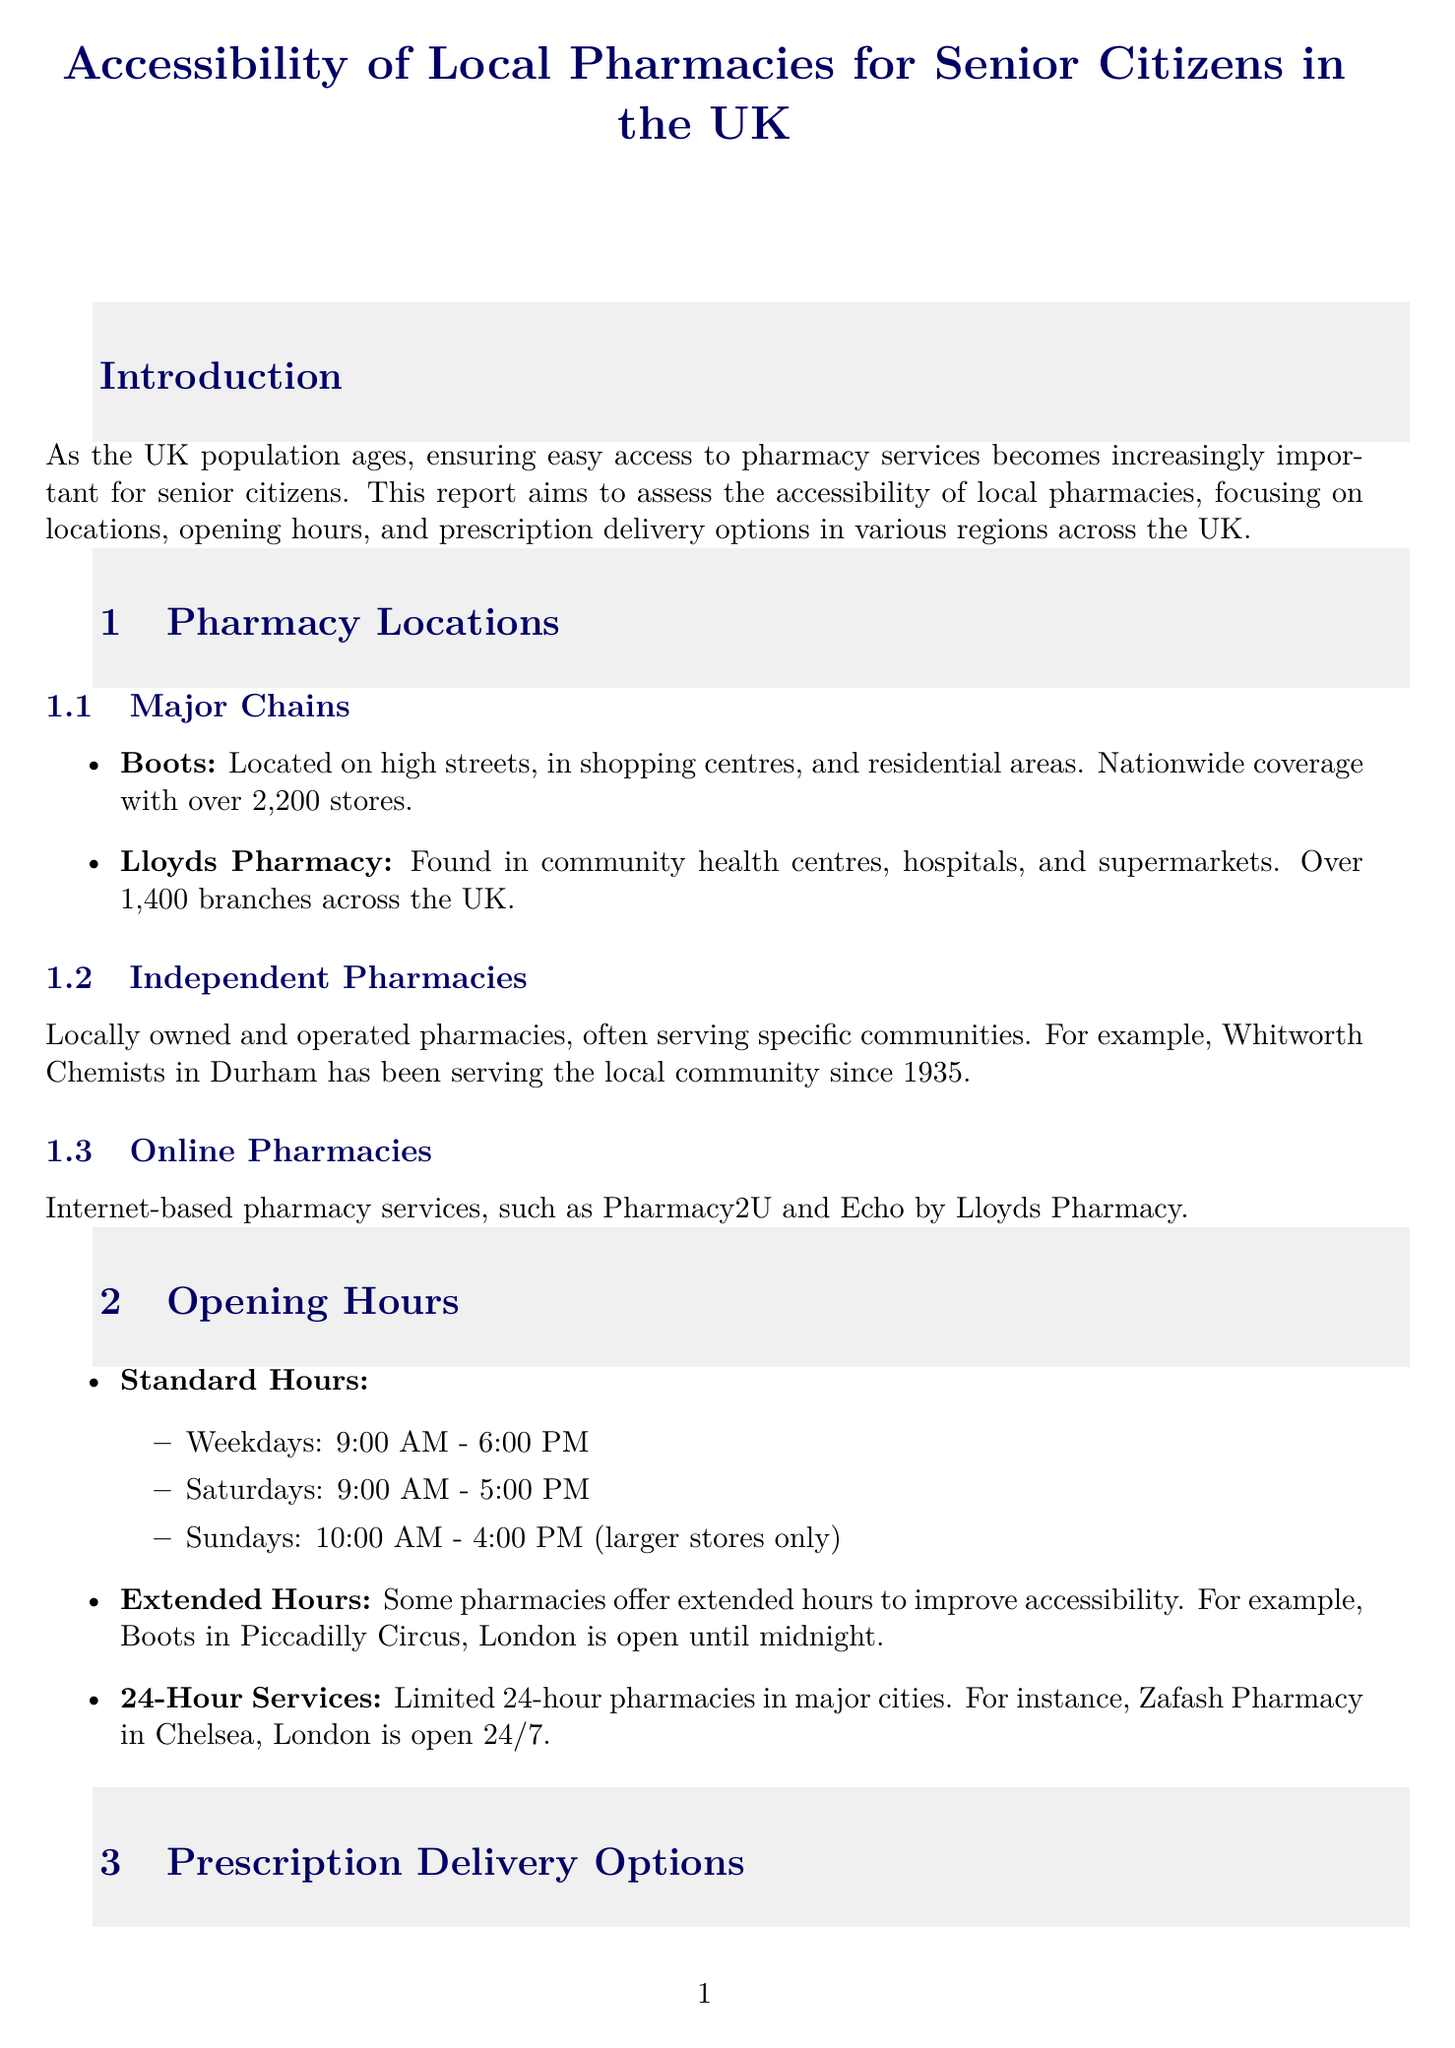What is the title of the report? The title of the report is provided at the beginning of the document, emphasizing its focus on local pharmacies for senior citizens in the UK.
Answer: Accessibility of Local Pharmacies for Senior Citizens in the UK How many Boots pharmacy stores are there nationwide? The document states that Boots has a nationwide coverage with over 2,200 stores.
Answer: over 2,200 stores What are the standard opening hours for pharmacies on weekdays? The document lists the standard opening hours for weekdays as 9:00 AM - 6:00 PM.
Answer: 9:00 AM - 6:00 PM Which service does Echo by Lloyds Pharmacy provide? The document describes Echo by Lloyds Pharmacy as a service that reminds patients when to order and delivers medications.
Answer: reminders for ordering and delivers medications What accessibility feature is essential for wheelchair users? The document mentions ramps as an essential feature for wheelchair users and those with mobility issues.
Answer: ramps What is one of the recommendations made in the conclusion? The document lists several recommendations, one of which is to increase funding for home delivery services.
Answer: Increase funding for home delivery services What is a challenge in Rural Cumbria according to the case studies? The case studies section highlights limited public transport and a sparse population as a challenge in Rural Cumbria.
Answer: Limited public transport and sparse population What is the coverage of Lloyds Pharmacy? The document states that Lloyds Pharmacy has over 1,400 branches across the UK.
Answer: over 1,400 branches What is one benefit of electronic prescription services? The document outlines that one benefit of electronic prescriptions is that it reduces the need for GP visits.
Answer: Reduces need for GP visits 